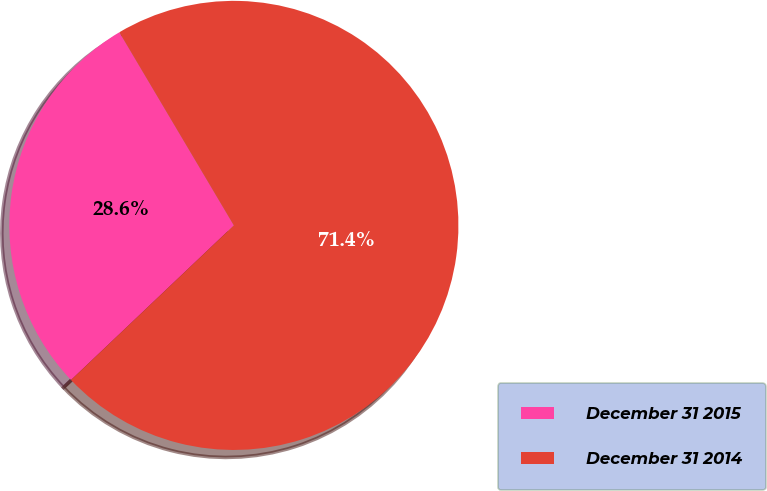Convert chart to OTSL. <chart><loc_0><loc_0><loc_500><loc_500><pie_chart><fcel>December 31 2015<fcel>December 31 2014<nl><fcel>28.57%<fcel>71.43%<nl></chart> 